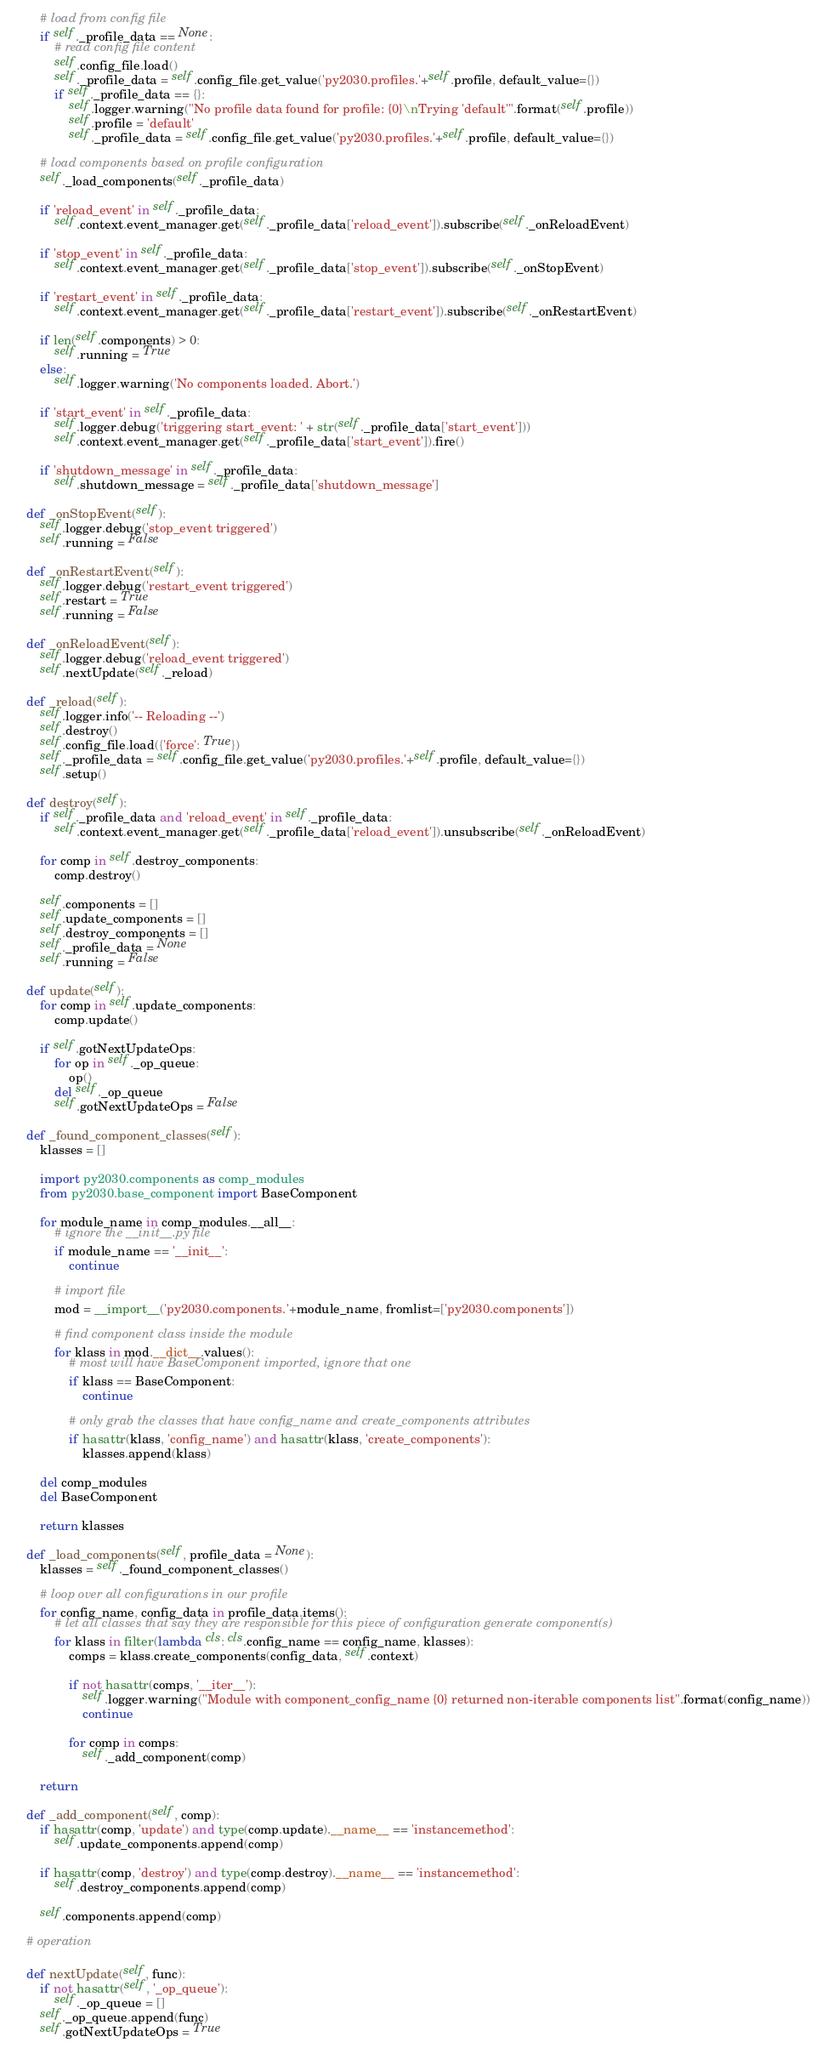<code> <loc_0><loc_0><loc_500><loc_500><_Python_>        # load from config file
        if self._profile_data == None:
            # read config file content
            self.config_file.load()
            self._profile_data = self.config_file.get_value('py2030.profiles.'+self.profile, default_value={})
            if self._profile_data == {}:
                self.logger.warning("No profile data found for profile: {0}\nTrying 'default'".format(self.profile))
                self.profile = 'default'
                self._profile_data = self.config_file.get_value('py2030.profiles.'+self.profile, default_value={})

        # load components based on profile configuration
        self._load_components(self._profile_data)

        if 'reload_event' in self._profile_data:
            self.context.event_manager.get(self._profile_data['reload_event']).subscribe(self._onReloadEvent)

        if 'stop_event' in self._profile_data:
            self.context.event_manager.get(self._profile_data['stop_event']).subscribe(self._onStopEvent)

        if 'restart_event' in self._profile_data:
            self.context.event_manager.get(self._profile_data['restart_event']).subscribe(self._onRestartEvent)

        if len(self.components) > 0:
            self.running = True
        else:
            self.logger.warning('No components loaded. Abort.')

        if 'start_event' in self._profile_data:
            self.logger.debug('triggering start_event: ' + str(self._profile_data['start_event']))
            self.context.event_manager.get(self._profile_data['start_event']).fire()

        if 'shutdown_message' in self._profile_data:
            self.shutdown_message = self._profile_data['shutdown_message']

    def _onStopEvent(self):
        self.logger.debug('stop_event triggered')
        self.running = False

    def _onRestartEvent(self):
        self.logger.debug('restart_event triggered')
        self.restart = True
        self.running = False

    def _onReloadEvent(self):
        self.logger.debug('reload_event triggered')
        self.nextUpdate(self._reload)

    def _reload(self):
        self.logger.info('-- Reloading --')
        self.destroy()
        self.config_file.load({'force': True})
        self._profile_data = self.config_file.get_value('py2030.profiles.'+self.profile, default_value={})
        self.setup()

    def destroy(self):
        if self._profile_data and 'reload_event' in self._profile_data:
            self.context.event_manager.get(self._profile_data['reload_event']).unsubscribe(self._onReloadEvent)

        for comp in self.destroy_components:
            comp.destroy()

        self.components = []
        self.update_components = []
        self.destroy_components = []
        self._profile_data = None
        self.running = False

    def update(self):
        for comp in self.update_components:
            comp.update()

        if self.gotNextUpdateOps:
            for op in self._op_queue:
                op()
            del self._op_queue
            self.gotNextUpdateOps = False

    def _found_component_classes(self):
        klasses = []

        import py2030.components as comp_modules
        from py2030.base_component import BaseComponent

        for module_name in comp_modules.__all__:
            # ignore the __init__.py file
            if module_name == '__init__':
                continue

            # import file
            mod = __import__('py2030.components.'+module_name, fromlist=['py2030.components'])

            # find component class inside the module
            for klass in mod.__dict__.values():
                # most will have BaseComponent imported, ignore that one
                if klass == BaseComponent:
                    continue

                # only grab the classes that have config_name and create_components attributes
                if hasattr(klass, 'config_name') and hasattr(klass, 'create_components'):
                    klasses.append(klass)

        del comp_modules
        del BaseComponent

        return klasses

    def _load_components(self, profile_data = None):
        klasses = self._found_component_classes()

        # loop over all configurations in our profile
        for config_name, config_data in profile_data.items():
            # let all classes that say they are responsible for this piece of configuration generate component(s)
            for klass in filter(lambda cls: cls.config_name == config_name, klasses):
                comps = klass.create_components(config_data, self.context)

                if not hasattr(comps, '__iter__'):
                    self.logger.warning("Module with component_config_name {0} returned non-iterable components list".format(config_name))
                    continue

                for comp in comps:
                    self._add_component(comp)

        return

    def _add_component(self, comp):
        if hasattr(comp, 'update') and type(comp.update).__name__ == 'instancemethod':
            self.update_components.append(comp)

        if hasattr(comp, 'destroy') and type(comp.destroy).__name__ == 'instancemethod':
            self.destroy_components.append(comp)

        self.components.append(comp)

    # operation

    def nextUpdate(self, func):
        if not hasattr(self, '_op_queue'):
            self._op_queue = []
        self._op_queue.append(func)
        self.gotNextUpdateOps = True
</code> 